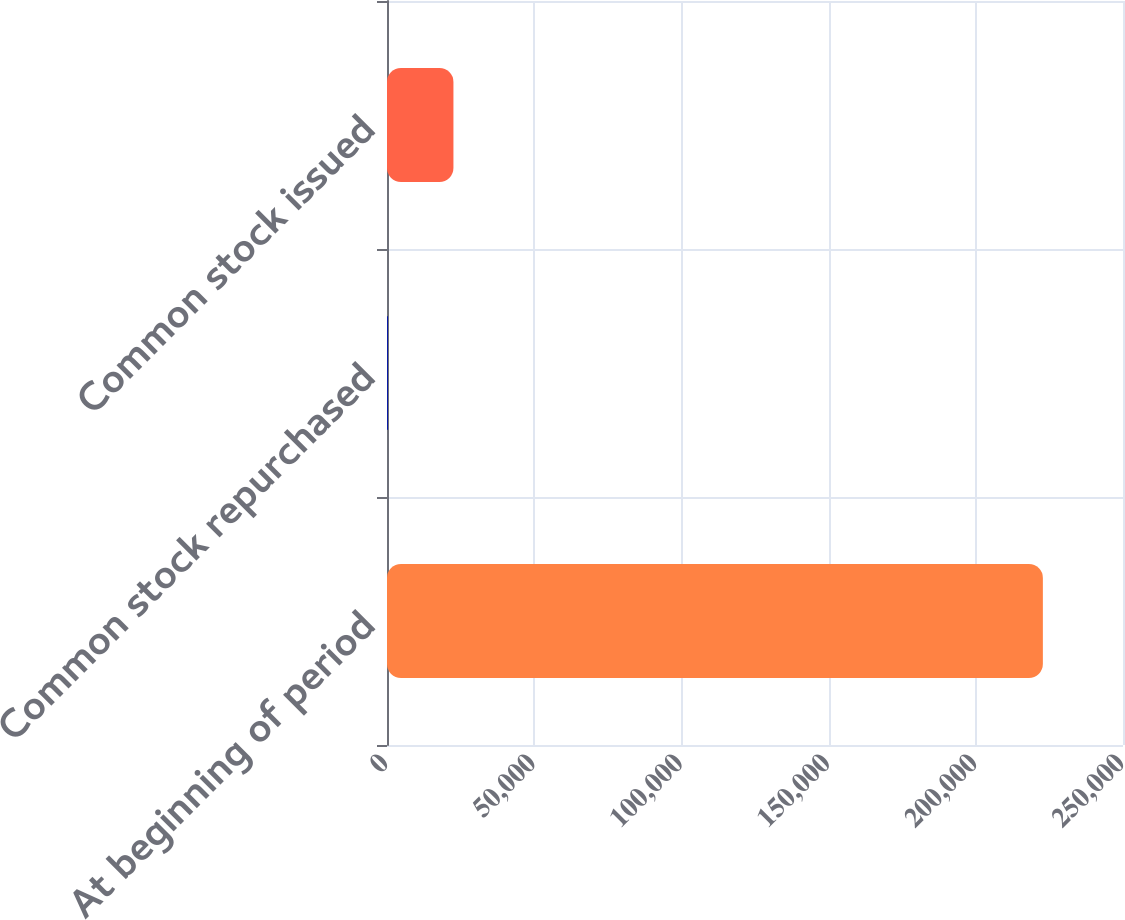Convert chart. <chart><loc_0><loc_0><loc_500><loc_500><bar_chart><fcel>At beginning of period<fcel>Common stock repurchased<fcel>Common stock issued<nl><fcel>222783<fcel>318<fcel>22564.5<nl></chart> 